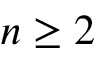Convert formula to latex. <formula><loc_0><loc_0><loc_500><loc_500>n \geq 2</formula> 